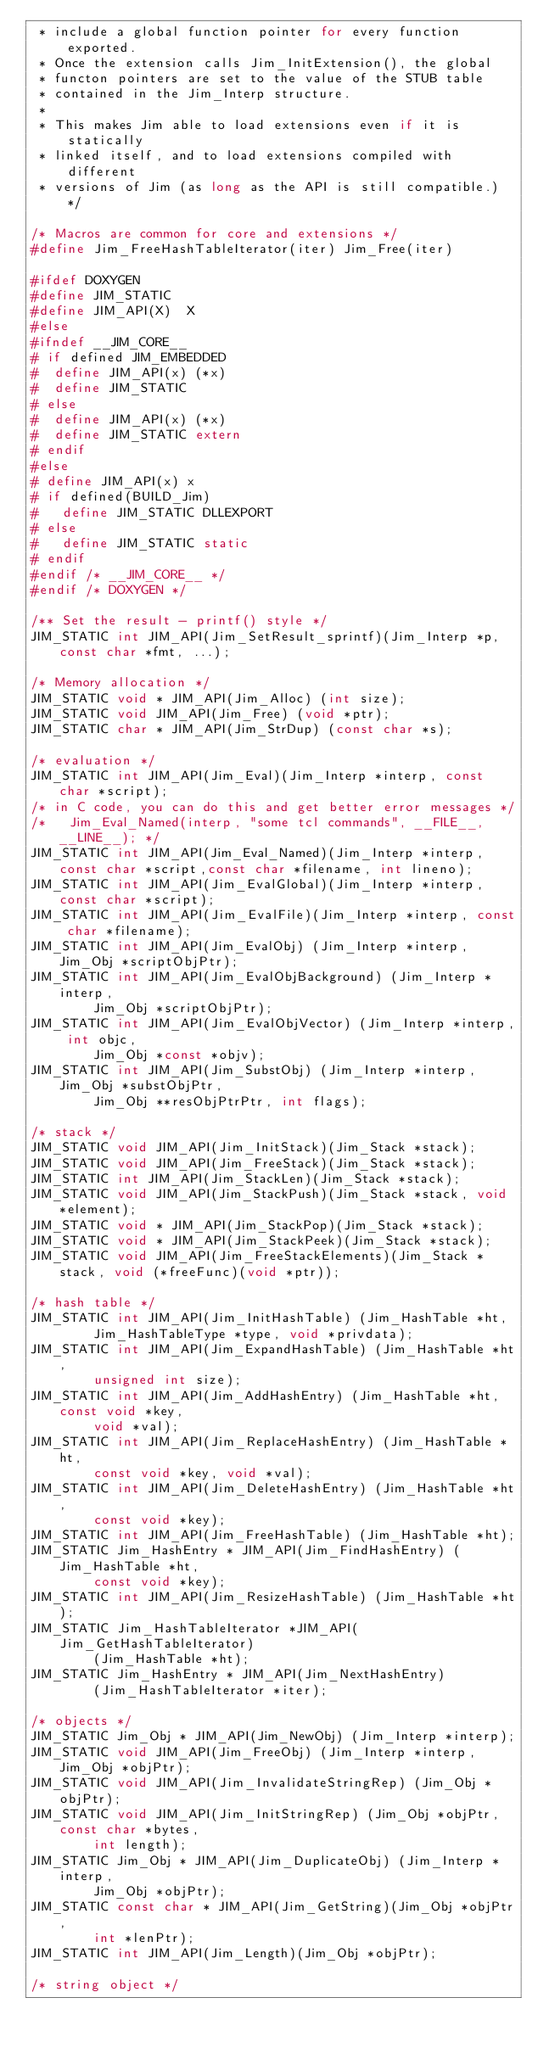Convert code to text. <code><loc_0><loc_0><loc_500><loc_500><_C_> * include a global function pointer for every function exported.
 * Once the extension calls Jim_InitExtension(), the global
 * functon pointers are set to the value of the STUB table
 * contained in the Jim_Interp structure.
 *
 * This makes Jim able to load extensions even if it is statically
 * linked itself, and to load extensions compiled with different
 * versions of Jim (as long as the API is still compatible.) */

/* Macros are common for core and extensions */
#define Jim_FreeHashTableIterator(iter) Jim_Free(iter)

#ifdef DOXYGEN
#define JIM_STATIC
#define JIM_API(X)  X
#else
#ifndef __JIM_CORE__
# if defined JIM_EMBEDDED
#  define JIM_API(x) (*x)
#  define JIM_STATIC
# else
#  define JIM_API(x) (*x)
#  define JIM_STATIC extern
# endif
#else
# define JIM_API(x) x
# if defined(BUILD_Jim)
#   define JIM_STATIC DLLEXPORT
# else
#   define JIM_STATIC static
# endif
#endif /* __JIM_CORE__ */
#endif /* DOXYGEN */

/** Set the result - printf() style */
JIM_STATIC int JIM_API(Jim_SetResult_sprintf)(Jim_Interp *p, const char *fmt, ...);

/* Memory allocation */
JIM_STATIC void * JIM_API(Jim_Alloc) (int size);
JIM_STATIC void JIM_API(Jim_Free) (void *ptr);
JIM_STATIC char * JIM_API(Jim_StrDup) (const char *s);

/* evaluation */
JIM_STATIC int JIM_API(Jim_Eval)(Jim_Interp *interp, const char *script);
/* in C code, you can do this and get better error messages */
/*   Jim_Eval_Named(interp, "some tcl commands", __FILE__, __LINE__); */
JIM_STATIC int JIM_API(Jim_Eval_Named)(Jim_Interp *interp, const char *script,const char *filename, int lineno);
JIM_STATIC int JIM_API(Jim_EvalGlobal)(Jim_Interp *interp, const char *script);
JIM_STATIC int JIM_API(Jim_EvalFile)(Jim_Interp *interp, const char *filename);
JIM_STATIC int JIM_API(Jim_EvalObj) (Jim_Interp *interp, Jim_Obj *scriptObjPtr);
JIM_STATIC int JIM_API(Jim_EvalObjBackground) (Jim_Interp *interp,
        Jim_Obj *scriptObjPtr);
JIM_STATIC int JIM_API(Jim_EvalObjVector) (Jim_Interp *interp, int objc,
        Jim_Obj *const *objv);
JIM_STATIC int JIM_API(Jim_SubstObj) (Jim_Interp *interp, Jim_Obj *substObjPtr,
        Jim_Obj **resObjPtrPtr, int flags);

/* stack */
JIM_STATIC void JIM_API(Jim_InitStack)(Jim_Stack *stack);
JIM_STATIC void JIM_API(Jim_FreeStack)(Jim_Stack *stack);
JIM_STATIC int JIM_API(Jim_StackLen)(Jim_Stack *stack);
JIM_STATIC void JIM_API(Jim_StackPush)(Jim_Stack *stack, void *element);
JIM_STATIC void * JIM_API(Jim_StackPop)(Jim_Stack *stack);
JIM_STATIC void * JIM_API(Jim_StackPeek)(Jim_Stack *stack);
JIM_STATIC void JIM_API(Jim_FreeStackElements)(Jim_Stack *stack, void (*freeFunc)(void *ptr));

/* hash table */
JIM_STATIC int JIM_API(Jim_InitHashTable) (Jim_HashTable *ht,
        Jim_HashTableType *type, void *privdata);
JIM_STATIC int JIM_API(Jim_ExpandHashTable) (Jim_HashTable *ht,
        unsigned int size);
JIM_STATIC int JIM_API(Jim_AddHashEntry) (Jim_HashTable *ht, const void *key,
        void *val);
JIM_STATIC int JIM_API(Jim_ReplaceHashEntry) (Jim_HashTable *ht,
        const void *key, void *val);
JIM_STATIC int JIM_API(Jim_DeleteHashEntry) (Jim_HashTable *ht,
        const void *key);
JIM_STATIC int JIM_API(Jim_FreeHashTable) (Jim_HashTable *ht);
JIM_STATIC Jim_HashEntry * JIM_API(Jim_FindHashEntry) (Jim_HashTable *ht,
        const void *key);
JIM_STATIC int JIM_API(Jim_ResizeHashTable) (Jim_HashTable *ht);
JIM_STATIC Jim_HashTableIterator *JIM_API(Jim_GetHashTableIterator)
        (Jim_HashTable *ht);
JIM_STATIC Jim_HashEntry * JIM_API(Jim_NextHashEntry)
        (Jim_HashTableIterator *iter);

/* objects */
JIM_STATIC Jim_Obj * JIM_API(Jim_NewObj) (Jim_Interp *interp);
JIM_STATIC void JIM_API(Jim_FreeObj) (Jim_Interp *interp, Jim_Obj *objPtr);
JIM_STATIC void JIM_API(Jim_InvalidateStringRep) (Jim_Obj *objPtr);
JIM_STATIC void JIM_API(Jim_InitStringRep) (Jim_Obj *objPtr, const char *bytes,
        int length);
JIM_STATIC Jim_Obj * JIM_API(Jim_DuplicateObj) (Jim_Interp *interp,
        Jim_Obj *objPtr);
JIM_STATIC const char * JIM_API(Jim_GetString)(Jim_Obj *objPtr,
        int *lenPtr);
JIM_STATIC int JIM_API(Jim_Length)(Jim_Obj *objPtr);

/* string object */</code> 